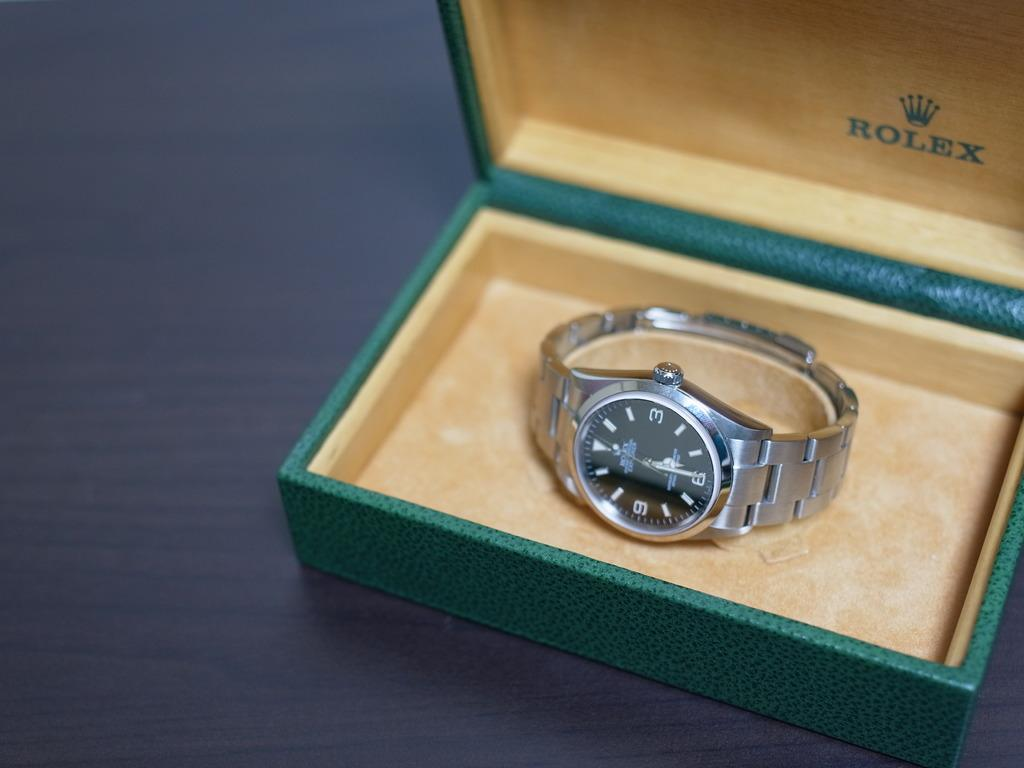<image>
Provide a brief description of the given image. A Rolex watch that is inside of a green case. 